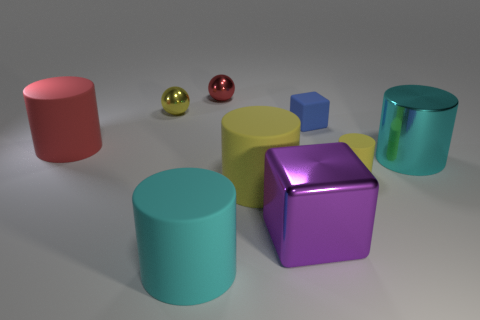Subtract all tiny yellow rubber cylinders. How many cylinders are left? 4 Add 1 yellow cylinders. How many objects exist? 10 Subtract all purple spheres. How many cyan cylinders are left? 2 Subtract all blocks. How many objects are left? 7 Subtract all cyan cylinders. How many cylinders are left? 3 Add 8 tiny red matte spheres. How many tiny red matte spheres exist? 8 Subtract 0 purple cylinders. How many objects are left? 9 Subtract 1 balls. How many balls are left? 1 Subtract all cyan blocks. Subtract all cyan cylinders. How many blocks are left? 2 Subtract all big brown metal things. Subtract all yellow shiny balls. How many objects are left? 8 